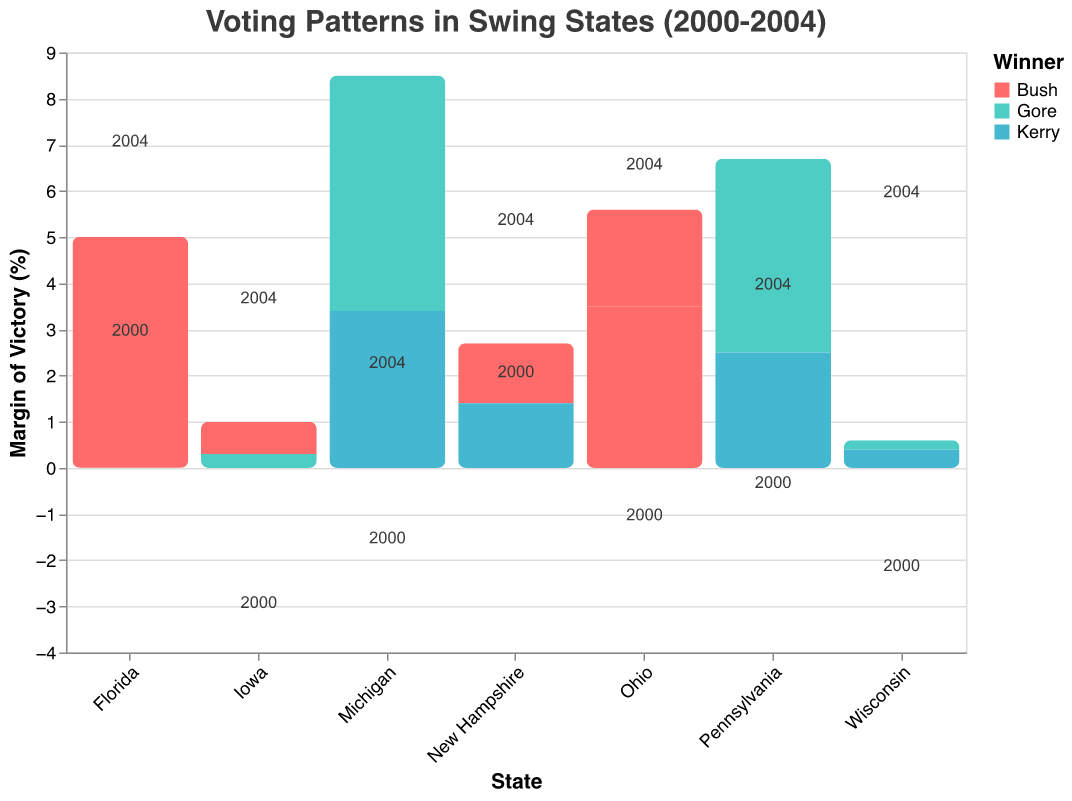What's the margin of victory for Bush in Florida in 2000? Simply locate Florida in the figure for the year 2000 and check Bush's margin of victory.
Answer: 0.01% How did voter turnout change in Ohio from 2000 to 2004? Compare the turnout change values for Ohio in 2000 and 2004.
Answer: Increased by 7.6% Which state had the biggest increase in voter turnout from 2000 to 2004? Look for the state with the highest positive turnout change value between 2000 and 2004.
Answer: Florida In which states did Bush win in 2000 but lose in 2004? Identify the states where Bush won in 2000 and then compare those states to who won in 2004.
Answer: New Hampshire What is the average margin of victory for Kerry in 2004 across the states where he won? Calculate the average margin for Kerry in 2004 for Pennsylvania, Michigan, Wisconsin, and New Hampshire. ((2.5 + 3.4 + 0.4 + 1.4) / 4)
Answer: 1.93% Which state shows the smallest margin of victory in 2004? Identify the state with the smallest margin value for the year 2004.
Answer: Wisconsin Compare Bush’s margin of victory in Ohio in 2000 and 2004. Which year did he perform better? Compare the margin values for Bush in Ohio in 2000 and 2004 to see which is larger.
Answer: 2000 What was the margin difference for Bush in Florida between 2000 and 2004? Subtract Bush's margin in 2000 from his margin in 2004 in Florida. (5.0% - 0.01%)
Answer: 4.99% Which state had a decrease in voter turnout from 2000 to 2004? Identify the states whose turnout change value is negative from 2000 to 2004.
Answer: None How many states flipped from Gore to Bush or Bush to Kerry from 2000 to 2004? Count the states where the winning candidate changed between 2000 and 2004.
Answer: 3 (Iowa, New Hampshire, and Pennsylvania) 